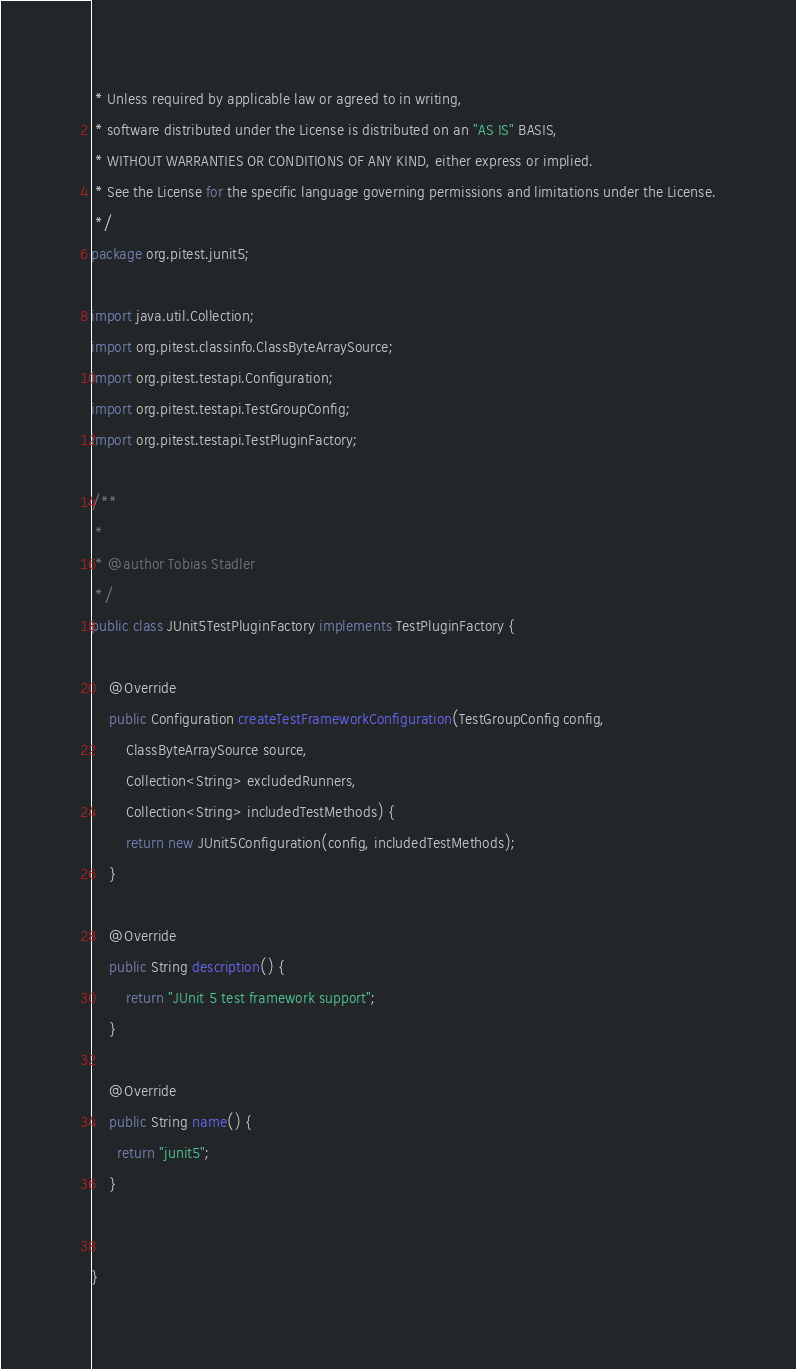Convert code to text. <code><loc_0><loc_0><loc_500><loc_500><_Java_> * Unless required by applicable law or agreed to in writing,
 * software distributed under the License is distributed on an "AS IS" BASIS,
 * WITHOUT WARRANTIES OR CONDITIONS OF ANY KIND, either express or implied.
 * See the License for the specific language governing permissions and limitations under the License.
 */
package org.pitest.junit5;

import java.util.Collection;
import org.pitest.classinfo.ClassByteArraySource;
import org.pitest.testapi.Configuration;
import org.pitest.testapi.TestGroupConfig;
import org.pitest.testapi.TestPluginFactory;

/**
 *
 * @author Tobias Stadler
 */
public class JUnit5TestPluginFactory implements TestPluginFactory {

    @Override
    public Configuration createTestFrameworkConfiguration(TestGroupConfig config, 
        ClassByteArraySource source, 
        Collection<String> excludedRunners,
        Collection<String> includedTestMethods) {
        return new JUnit5Configuration(config, includedTestMethods);
    }

    @Override
    public String description() {
        return "JUnit 5 test framework support";
    }

    @Override
    public String name() {
      return "junit5";
    }


}
</code> 